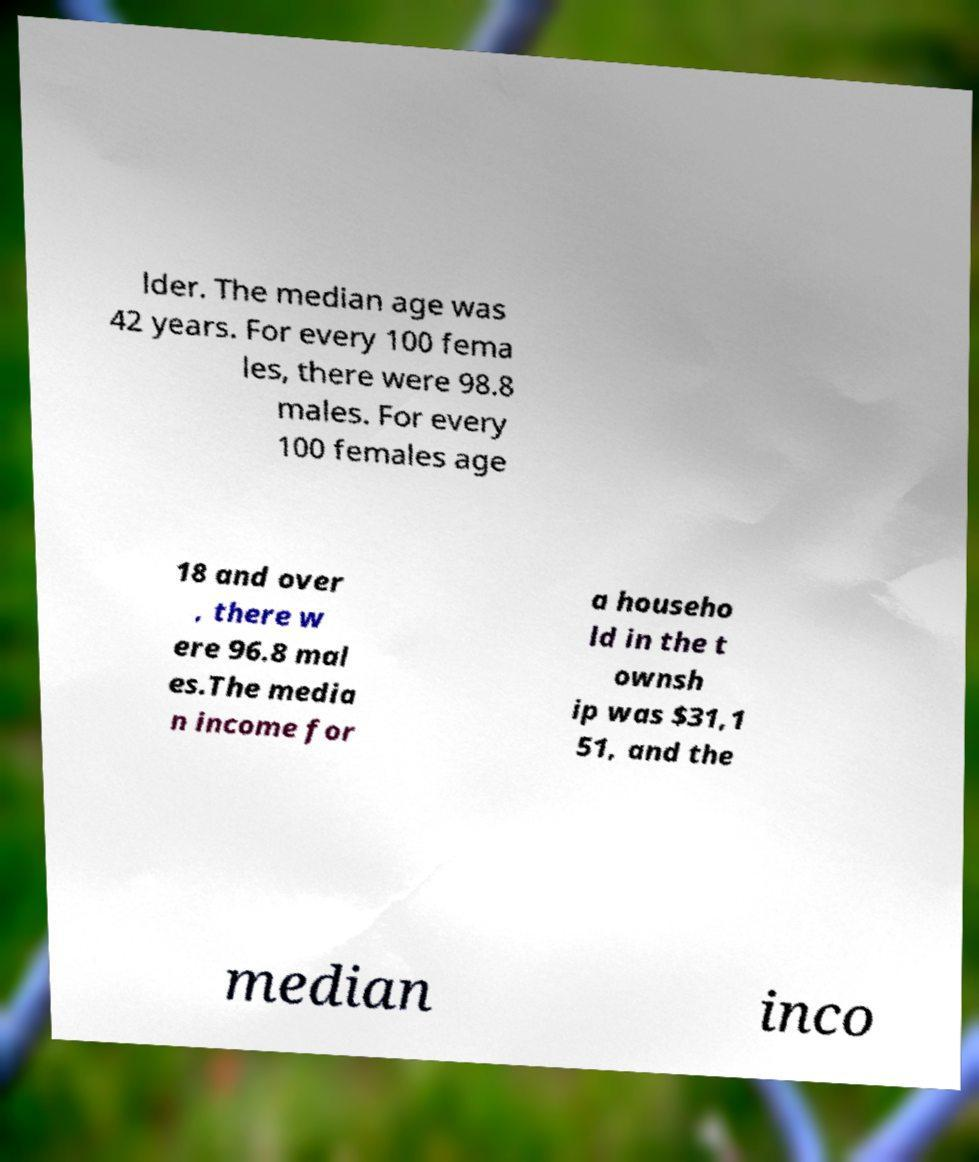Could you extract and type out the text from this image? lder. The median age was 42 years. For every 100 fema les, there were 98.8 males. For every 100 females age 18 and over , there w ere 96.8 mal es.The media n income for a househo ld in the t ownsh ip was $31,1 51, and the median inco 